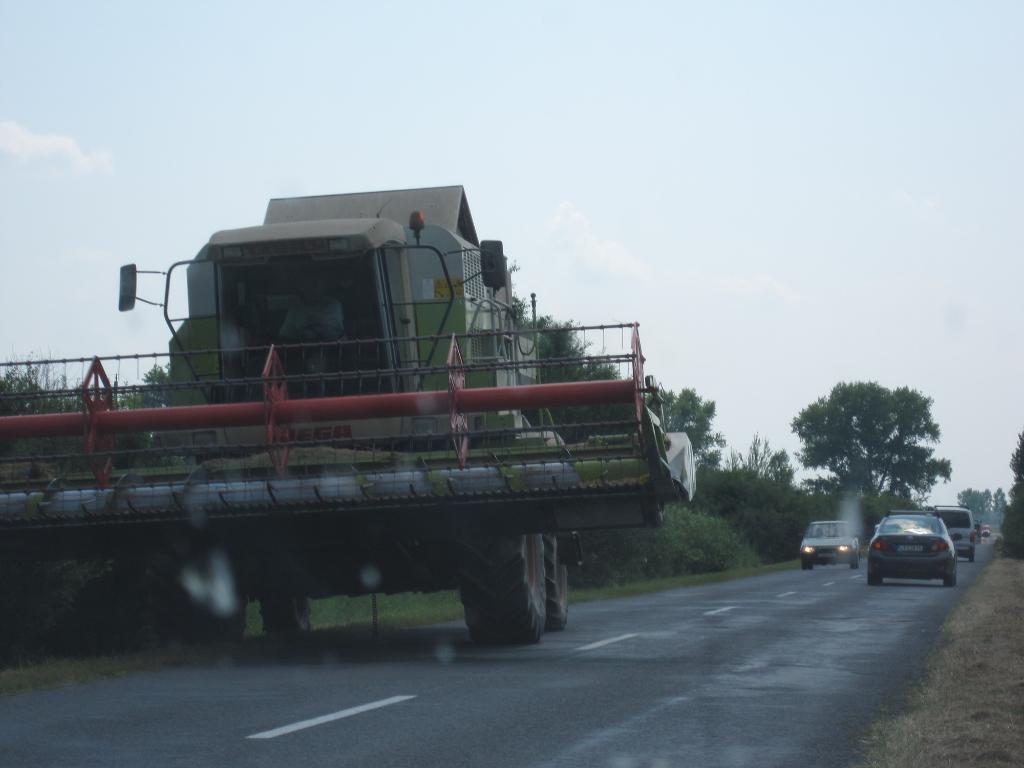In one or two sentences, can you explain what this image depicts? In this image there is a road, on road there are cars and a person sitting on the truck. At the side there are trees and a sky. 